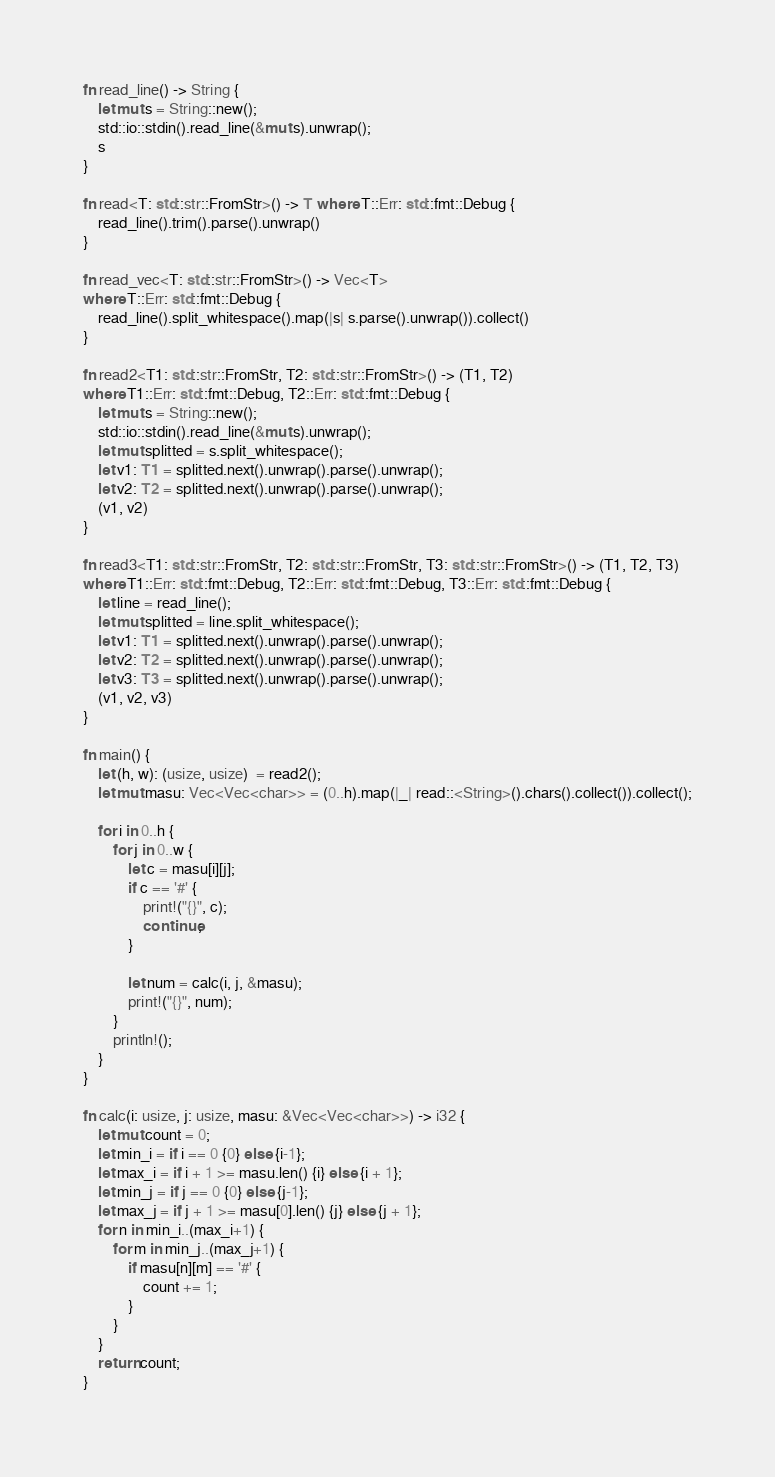Convert code to text. <code><loc_0><loc_0><loc_500><loc_500><_Rust_>fn read_line() -> String {
    let mut s = String::new();
    std::io::stdin().read_line(&mut s).unwrap();
    s
}

fn read<T: std::str::FromStr>() -> T where T::Err: std::fmt::Debug {
    read_line().trim().parse().unwrap()
}

fn read_vec<T: std::str::FromStr>() -> Vec<T>
where T::Err: std::fmt::Debug {
    read_line().split_whitespace().map(|s| s.parse().unwrap()).collect()
}

fn read2<T1: std::str::FromStr, T2: std::str::FromStr>() -> (T1, T2)
where T1::Err: std::fmt::Debug, T2::Err: std::fmt::Debug {
    let mut s = String::new();
    std::io::stdin().read_line(&mut s).unwrap();
    let mut splitted = s.split_whitespace();
    let v1: T1 = splitted.next().unwrap().parse().unwrap();
    let v2: T2 = splitted.next().unwrap().parse().unwrap();
    (v1, v2)
}

fn read3<T1: std::str::FromStr, T2: std::str::FromStr, T3: std::str::FromStr>() -> (T1, T2, T3)
where T1::Err: std::fmt::Debug, T2::Err: std::fmt::Debug, T3::Err: std::fmt::Debug {
    let line = read_line();
    let mut splitted = line.split_whitespace();
    let v1: T1 = splitted.next().unwrap().parse().unwrap();
    let v2: T2 = splitted.next().unwrap().parse().unwrap();
    let v3: T3 = splitted.next().unwrap().parse().unwrap();
    (v1, v2, v3)
}

fn main() {
    let (h, w): (usize, usize)  = read2();
    let mut masu: Vec<Vec<char>> = (0..h).map(|_| read::<String>().chars().collect()).collect();

    for i in 0..h {
        for j in 0..w {
            let c = masu[i][j];
            if c == '#' {
                print!("{}", c);
                continue;
            }

            let num = calc(i, j, &masu);
            print!("{}", num);
        }
        println!();
    }
}

fn calc(i: usize, j: usize, masu: &Vec<Vec<char>>) -> i32 {
    let mut count = 0;
    let min_i = if i == 0 {0} else {i-1};
    let max_i = if i + 1 >= masu.len() {i} else {i + 1};
    let min_j = if j == 0 {0} else {j-1};
    let max_j = if j + 1 >= masu[0].len() {j} else {j + 1};
    for n in min_i..(max_i+1) {
        for m in min_j..(max_j+1) {
            if masu[n][m] == '#' {
                count += 1;
            }
        }
    }
    return count;
}</code> 